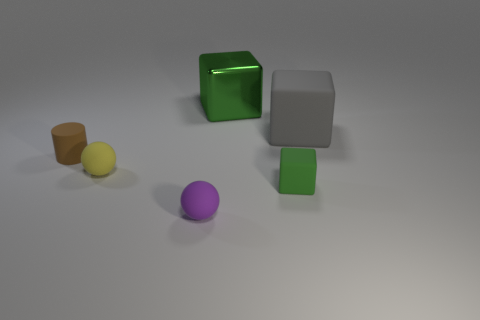Is the big metallic block the same color as the tiny matte block?
Your answer should be compact. Yes. Are the green thing that is behind the small brown matte cylinder and the block that is in front of the cylinder made of the same material?
Offer a terse response. No. What material is the sphere in front of the sphere left of the purple rubber sphere?
Offer a terse response. Rubber. There is a green cube to the right of the block that is to the left of the small object on the right side of the purple object; what size is it?
Your answer should be very brief. Small. Do the green matte cube and the metallic thing have the same size?
Your answer should be very brief. No. There is a matte thing left of the yellow rubber thing; is its shape the same as the large thing behind the gray matte object?
Offer a terse response. No. Are there any things in front of the big cube that is left of the large gray matte thing?
Your answer should be very brief. Yes. Is there a large ball?
Ensure brevity in your answer.  No. How many shiny objects are the same size as the gray rubber cube?
Offer a terse response. 1. What number of matte objects are to the left of the green matte block and behind the tiny green object?
Your answer should be very brief. 2. 